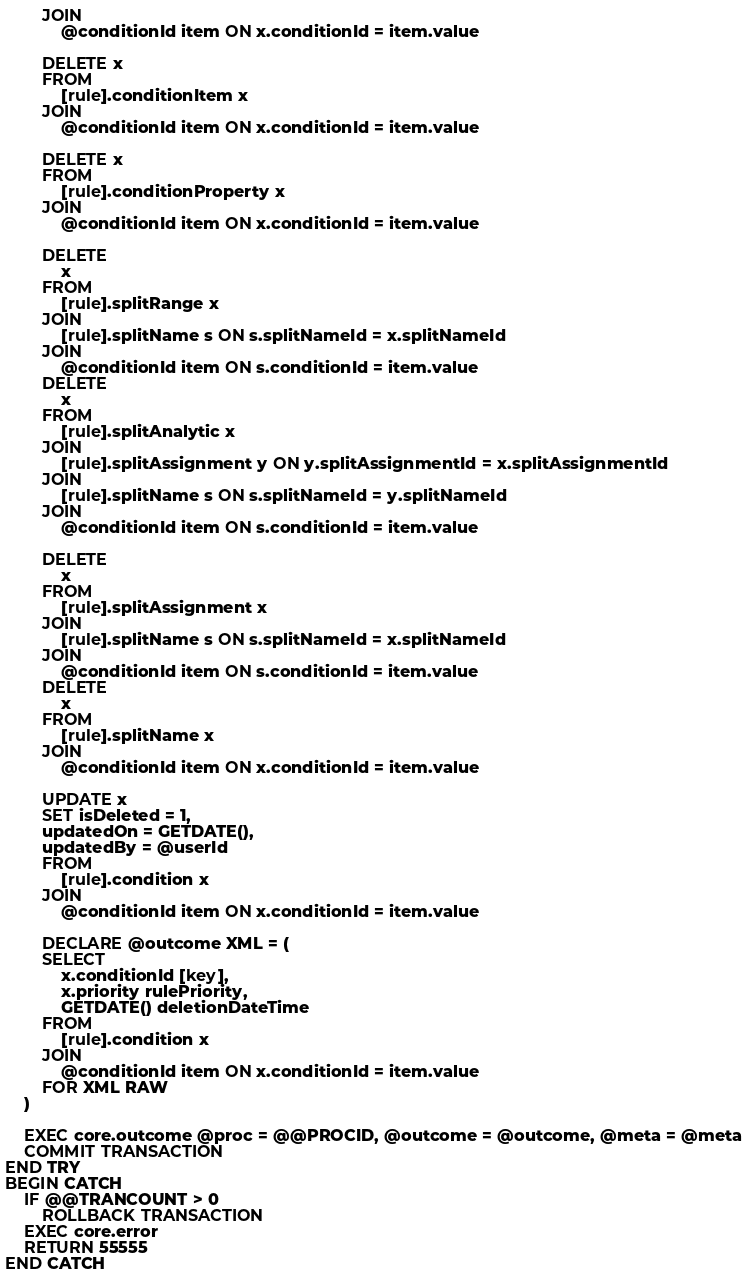<code> <loc_0><loc_0><loc_500><loc_500><_SQL_>        JOIN
            @conditionId item ON x.conditionId = item.value

        DELETE x
        FROM
            [rule].conditionItem x
        JOIN
            @conditionId item ON x.conditionId = item.value

        DELETE x
        FROM
            [rule].conditionProperty x
        JOIN
            @conditionId item ON x.conditionId = item.value

        DELETE
            x
        FROM
            [rule].splitRange x
        JOIN
            [rule].splitName s ON s.splitNameId = x.splitNameId
        JOIN
            @conditionId item ON s.conditionId = item.value
        DELETE
            x
        FROM
            [rule].splitAnalytic x
        JOIN
            [rule].splitAssignment y ON y.splitAssignmentId = x.splitAssignmentId
        JOIN
            [rule].splitName s ON s.splitNameId = y.splitNameId
        JOIN
            @conditionId item ON s.conditionId = item.value

        DELETE
            x
        FROM
            [rule].splitAssignment x
        JOIN
            [rule].splitName s ON s.splitNameId = x.splitNameId
        JOIN
            @conditionId item ON s.conditionId = item.value
        DELETE
            x
        FROM
            [rule].splitName x
        JOIN
            @conditionId item ON x.conditionId = item.value

        UPDATE x
        SET isDeleted = 1,
        updatedOn = GETDATE(),
        updatedBy = @userId
        FROM
            [rule].condition x
        JOIN
            @conditionId item ON x.conditionId = item.value

        DECLARE @outcome XML = (
        SELECT
            x.conditionId [key],
            x.priority rulePriority,
            GETDATE() deletionDateTime
        FROM
            [rule].condition x
        JOIN
            @conditionId item ON x.conditionId = item.value
        FOR XML RAW
    )

    EXEC core.outcome @proc = @@PROCID, @outcome = @outcome, @meta = @meta
    COMMIT TRANSACTION
END TRY
BEGIN CATCH
    IF @@TRANCOUNT > 0
        ROLLBACK TRANSACTION
    EXEC core.error
    RETURN 55555
END CATCH
</code> 